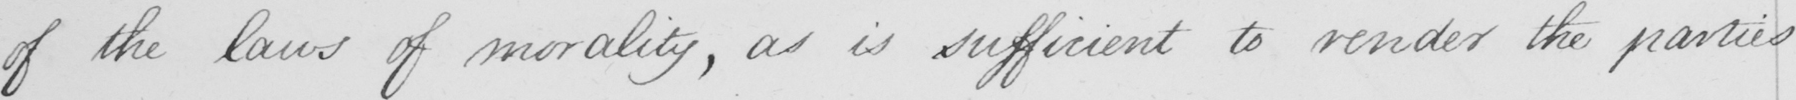What text is written in this handwritten line? of the laws of morality , as is sufficient to render the parties 